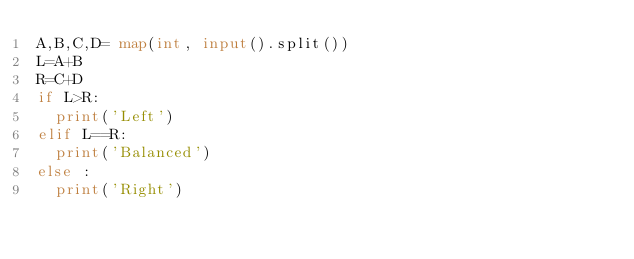<code> <loc_0><loc_0><loc_500><loc_500><_Python_>A,B,C,D= map(int, input().split())
L=A+B
R=C+D
if L>R:
  print('Left')
elif L==R:
  print('Balanced')
else :
  print('Right')
</code> 